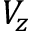Convert formula to latex. <formula><loc_0><loc_0><loc_500><loc_500>V _ { z }</formula> 